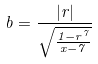Convert formula to latex. <formula><loc_0><loc_0><loc_500><loc_500>b = \frac { | r | } { \sqrt { \frac { 1 - r ^ { 7 } } { x - 7 } } }</formula> 